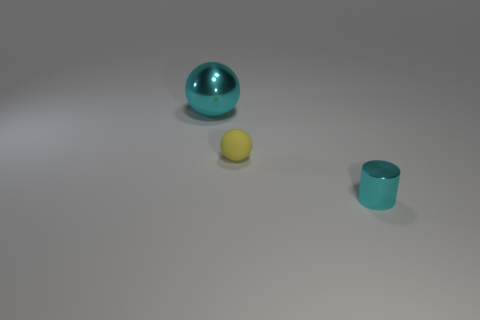Add 1 big metallic spheres. How many objects exist? 4 Subtract all spheres. How many objects are left? 1 Subtract all cyan spheres. Subtract all large purple rubber spheres. How many objects are left? 2 Add 2 matte things. How many matte things are left? 3 Add 1 big cyan spheres. How many big cyan spheres exist? 2 Subtract 0 yellow blocks. How many objects are left? 3 